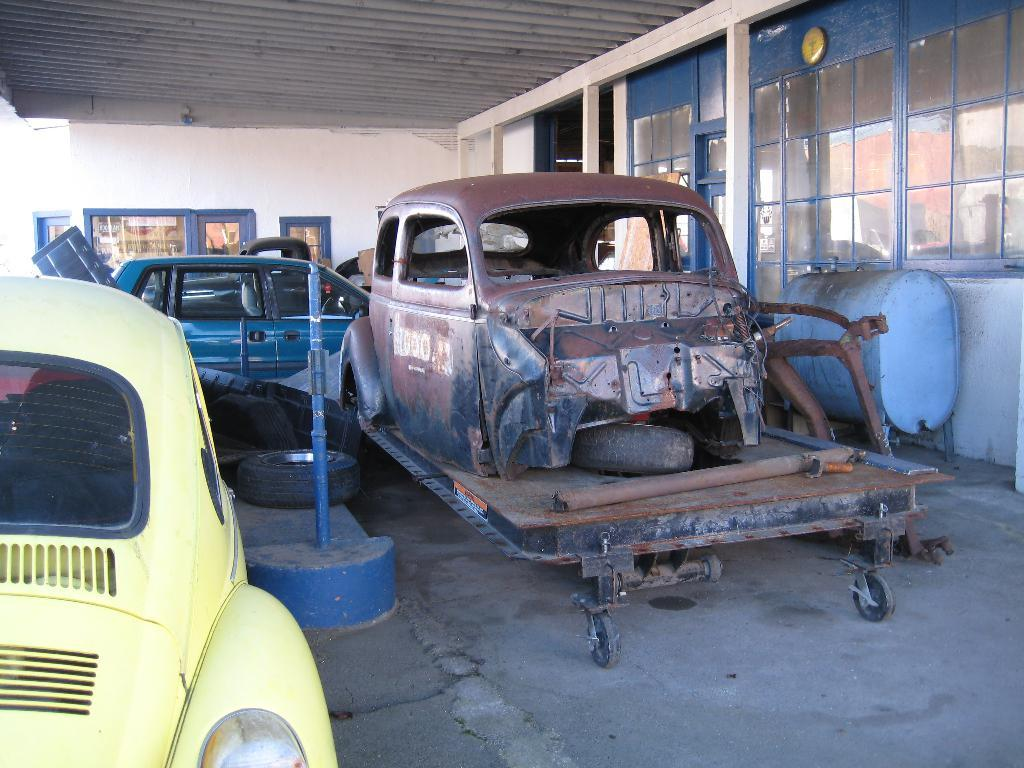What type of objects can be seen in the image? There are vehicles in the image. What part of the vehicles is visible in the image? There are tires in the image. What can be seen in the background of the image? There is a wall and glasses in the background of the image. What type of holiday is being celebrated in the image? There is no indication of a holiday being celebrated in the image. What is the stem of the vehicle in the image? The image does not show a vehicle with a stem. 